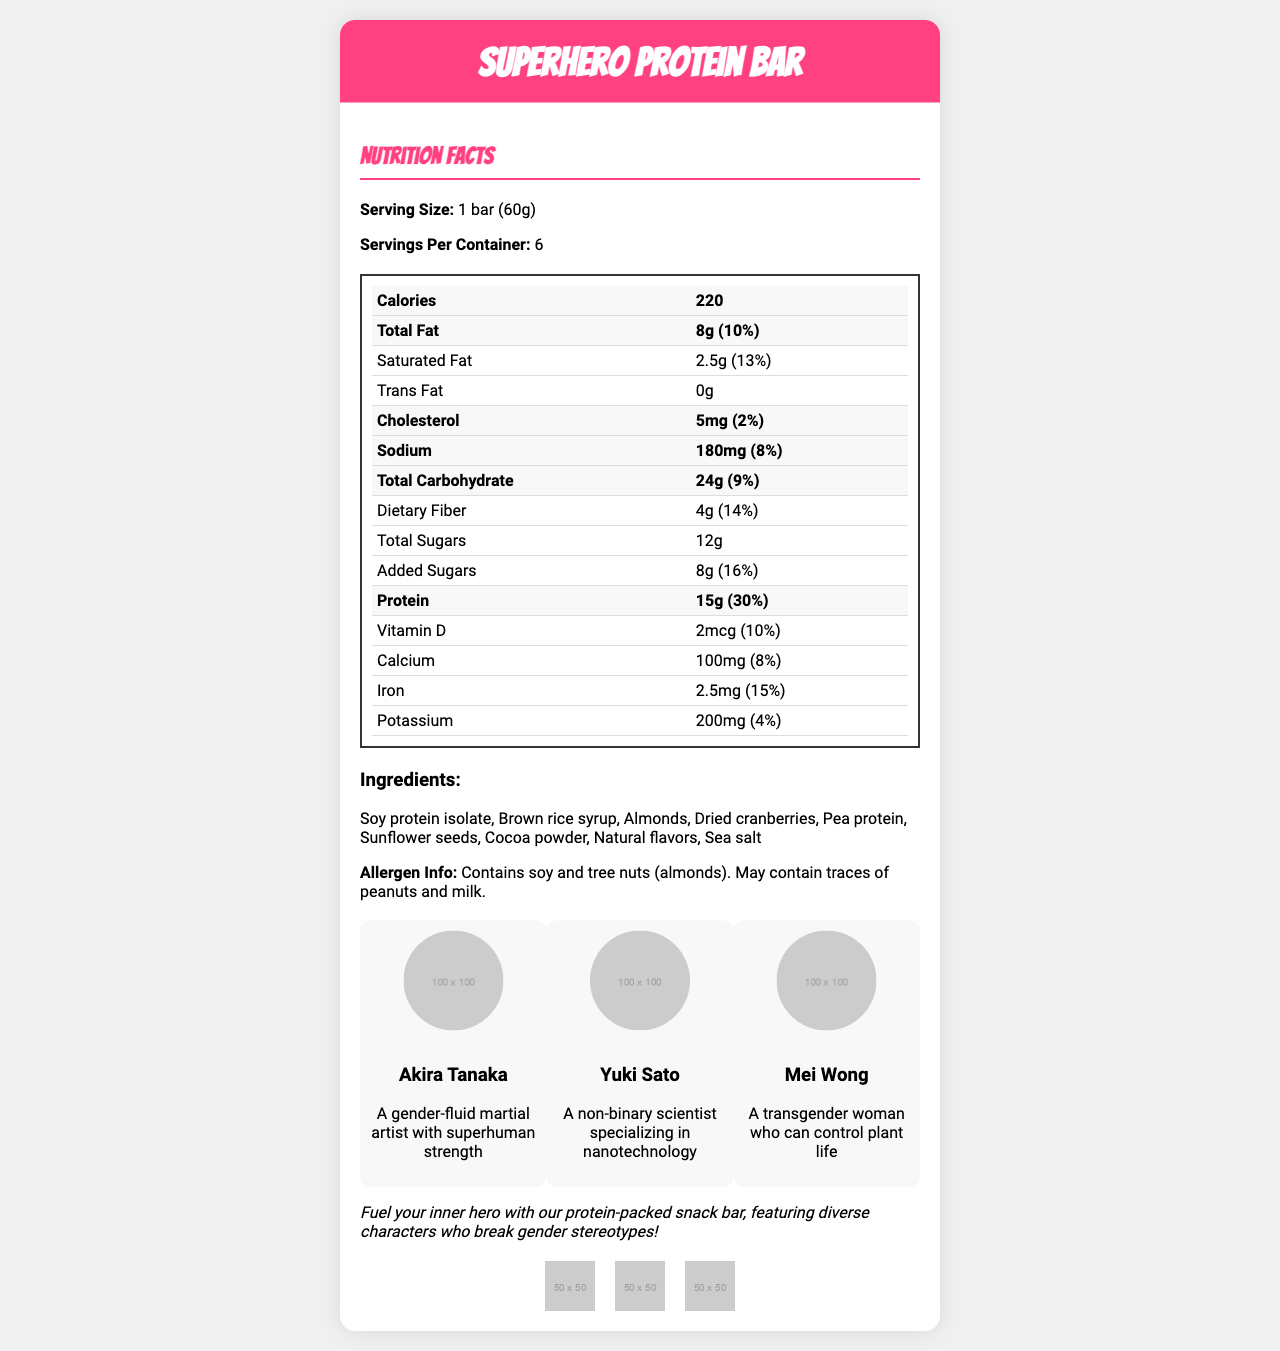what is the serving size of the SuperHero Protein Bar? The serving size is clearly stated as "1 bar (60g)" in the Nutrition Facts section.
Answer: 1 bar (60g) how many calories are in one serving of the SuperHero Protein Bar? The document specifies that each serving of the protein bar contains 220 calories.
Answer: 220 what percentage of daily value of protein does one serving of the SuperHero Protein Bar provide? The document lists the amount of protein as 15g, with a daily value of 30%.
Answer: 30% how many servings are there per container? The document states that there are 6 servings per container.
Answer: 6 what are the core ingredients of the SuperHero Protein Bar? The document lists the ingredients in the ingredients section.
Answer: Soy protein isolate, Brown rice syrup, Almonds, Dried cranberries, Pea protein, Sunflower seeds, Cocoa powder, Natural flavors, Sea salt how much fiber is in one serving? The document states that each serving contains 4g of dietary fiber.
Answer: 4g which of the following is true about the certification logos on the product? 1. The product is Organic Certified 2. The product is Vegan Certified 3. The product is Fair Trade Certified 4. The product has no certifications The document shows certification logos including "Vegan Certified."
Answer: 2. The product is Vegan Certified who is the character described as "A non-binary scientist specializing in nanotechnology"? A. Akira Tanaka B. Yuki Sato C. Mei Wong D. None of the above Yuki Sato is described as a non-binary scientist specializing in nanotechnology in the characters section.
Answer: B. Yuki Sato does the product contain tree nuts? The allergen information indicates that the product contains almonds, which are tree nuts.
Answer: Yes summarize the main idea of the document. The document focuses on the nutritional details and unique features of a protein-packed snack bar represented by diverse manga characters who challenge gender roles.
Answer: Fuel your inner hero with the SuperHero Protein Bar, featuring diverse manga characters who break gender stereotypes. The nutrition label provides details on the caloric content, macronutrients, and vitamins. The product is Vegan Certified, Non-GMO Project Verified, and gluten-free, with allergen information included. what are the health benefits of consuming protein? The document provides nutritional information but does not describe the health benefits of consuming protein.
Answer: Not enough information 